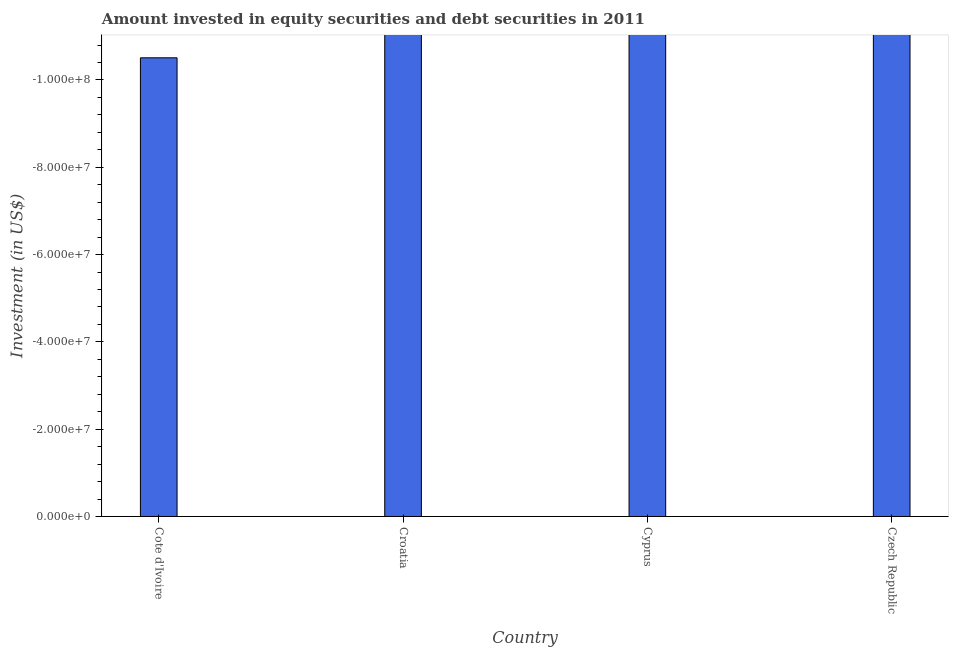Does the graph contain grids?
Offer a terse response. No. What is the title of the graph?
Provide a short and direct response. Amount invested in equity securities and debt securities in 2011. What is the label or title of the Y-axis?
Give a very brief answer. Investment (in US$). What is the portfolio investment in Cote d'Ivoire?
Keep it short and to the point. 0. What is the sum of the portfolio investment?
Ensure brevity in your answer.  0. What is the average portfolio investment per country?
Your answer should be compact. 0. Are all the bars in the graph horizontal?
Your answer should be very brief. No. What is the difference between two consecutive major ticks on the Y-axis?
Keep it short and to the point. 2.00e+07. What is the Investment (in US$) of Cote d'Ivoire?
Give a very brief answer. 0. What is the Investment (in US$) in Croatia?
Ensure brevity in your answer.  0. What is the Investment (in US$) in Cyprus?
Give a very brief answer. 0. What is the Investment (in US$) of Czech Republic?
Offer a terse response. 0. 